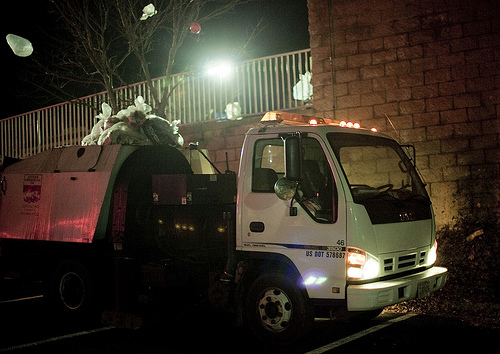<image>
Is the tire in the headlight? No. The tire is not contained within the headlight. These objects have a different spatial relationship. 